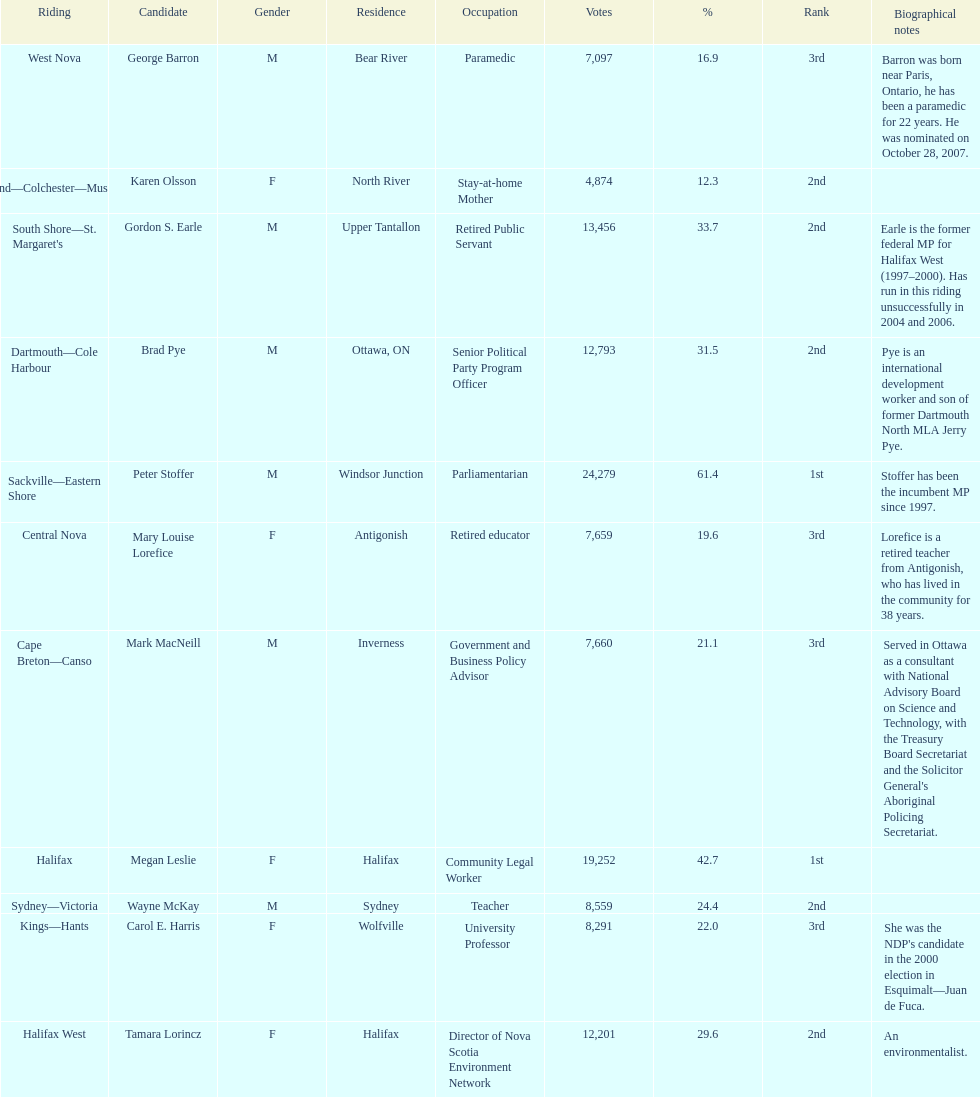How many of the applicants were females? 5. 